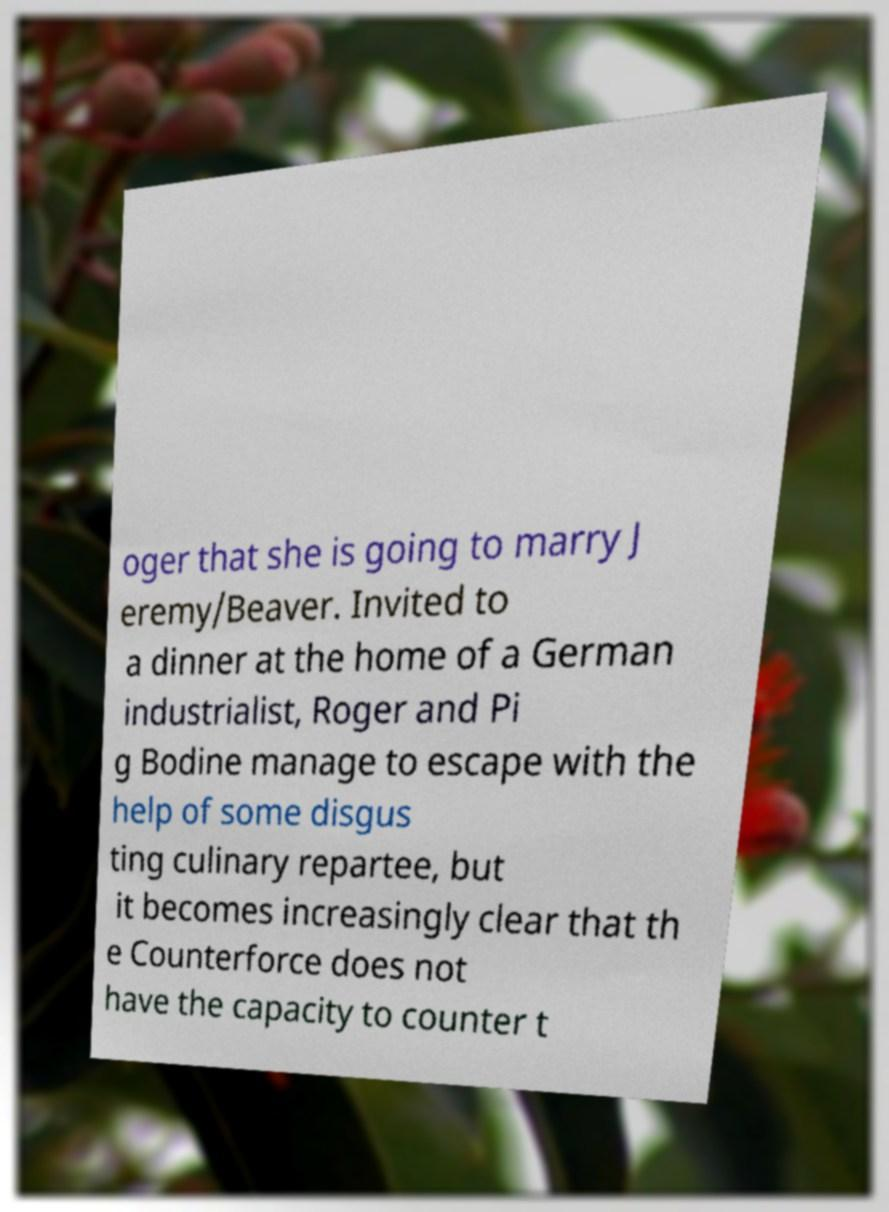For documentation purposes, I need the text within this image transcribed. Could you provide that? oger that she is going to marry J eremy/Beaver. Invited to a dinner at the home of a German industrialist, Roger and Pi g Bodine manage to escape with the help of some disgus ting culinary repartee, but it becomes increasingly clear that th e Counterforce does not have the capacity to counter t 